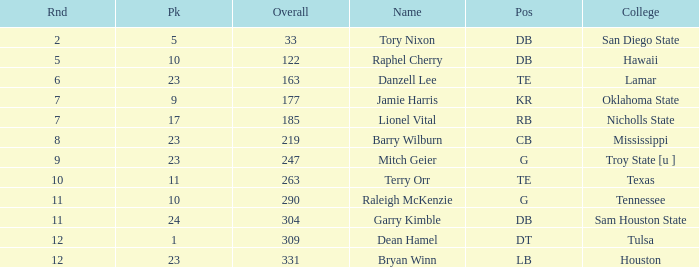How many Picks have a College of hawaii, and an Overall smaller than 122? 0.0. 